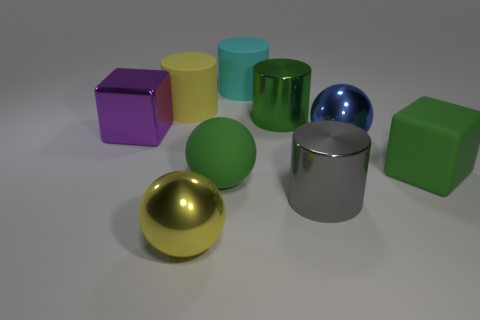Can you describe the textures and materials of the objects in the image? Certainly! The objects exhibit a variety of textures and materials. The silver cylinder and the golden sphere have reflective surfaces suggesting they are made of polished metal. The cyan object has a matte rubber-like texture. The green cube appears to be of a solid, possibly plastic matte finish, and the purple cube looks to have a slightly reflective plastic surface as well. 